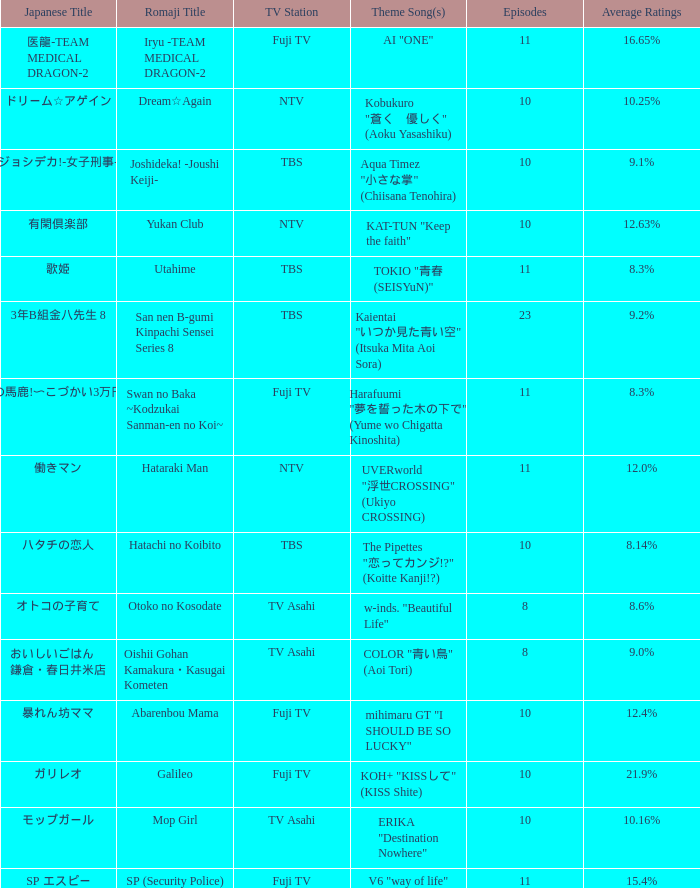What Episode has a Theme Song of koh+ "kissして" (kiss shite)? 10.0. 